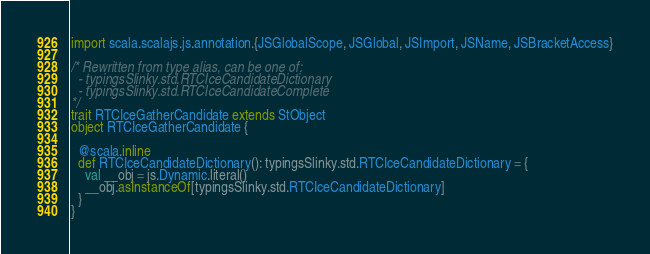Convert code to text. <code><loc_0><loc_0><loc_500><loc_500><_Scala_>import scala.scalajs.js.annotation.{JSGlobalScope, JSGlobal, JSImport, JSName, JSBracketAccess}

/* Rewritten from type alias, can be one of: 
  - typingsSlinky.std.RTCIceCandidateDictionary
  - typingsSlinky.std.RTCIceCandidateComplete
*/
trait RTCIceGatherCandidate extends StObject
object RTCIceGatherCandidate {
  
  @scala.inline
  def RTCIceCandidateDictionary(): typingsSlinky.std.RTCIceCandidateDictionary = {
    val __obj = js.Dynamic.literal()
    __obj.asInstanceOf[typingsSlinky.std.RTCIceCandidateDictionary]
  }
}
</code> 